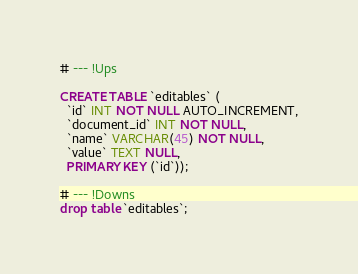Convert code to text. <code><loc_0><loc_0><loc_500><loc_500><_SQL_>
# --- !Ups

CREATE TABLE `editables` (
  `id` INT NOT NULL AUTO_INCREMENT,
  `document_id` INT NOT NULL,
  `name` VARCHAR(45) NOT NULL,
  `value` TEXT NULL,
  PRIMARY KEY (`id`));

# --- !Downs
drop table `editables`;</code> 